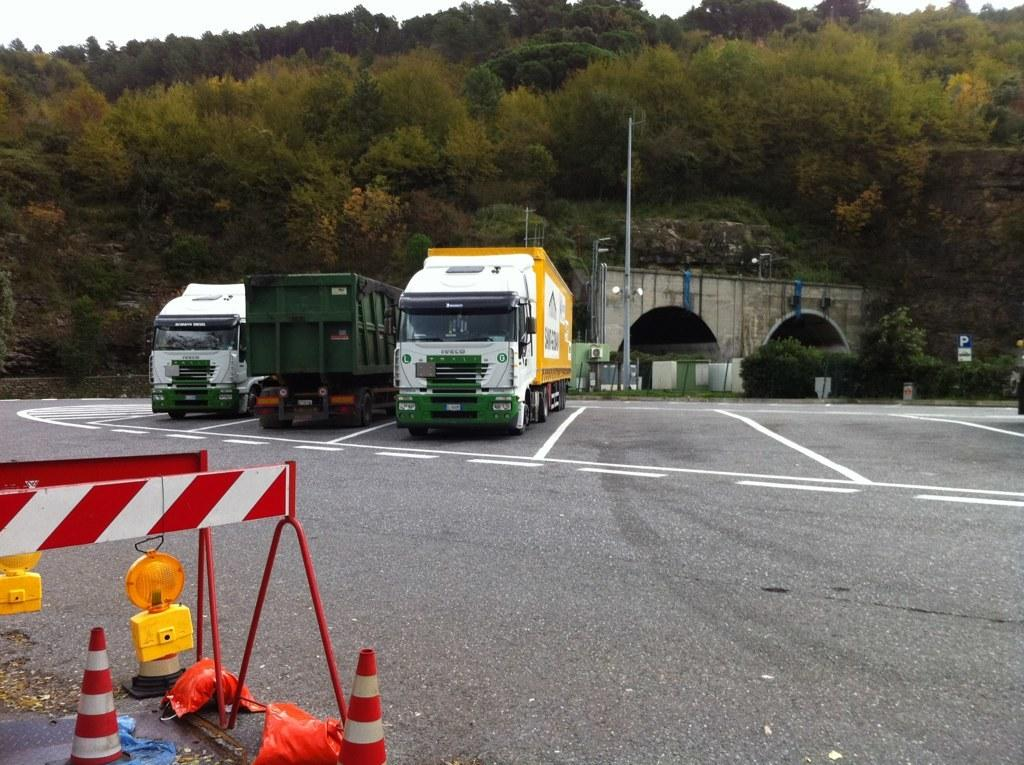What can be seen on the road in the image? There are vehicles on the road in the image. What type of natural elements are visible in the image? There are trees visible in the image. Where is the dad in the image? There is no dad present in the image. Are the trees in the image crying? Trees do not have the ability to cry, so this cannot be observed in the image. 